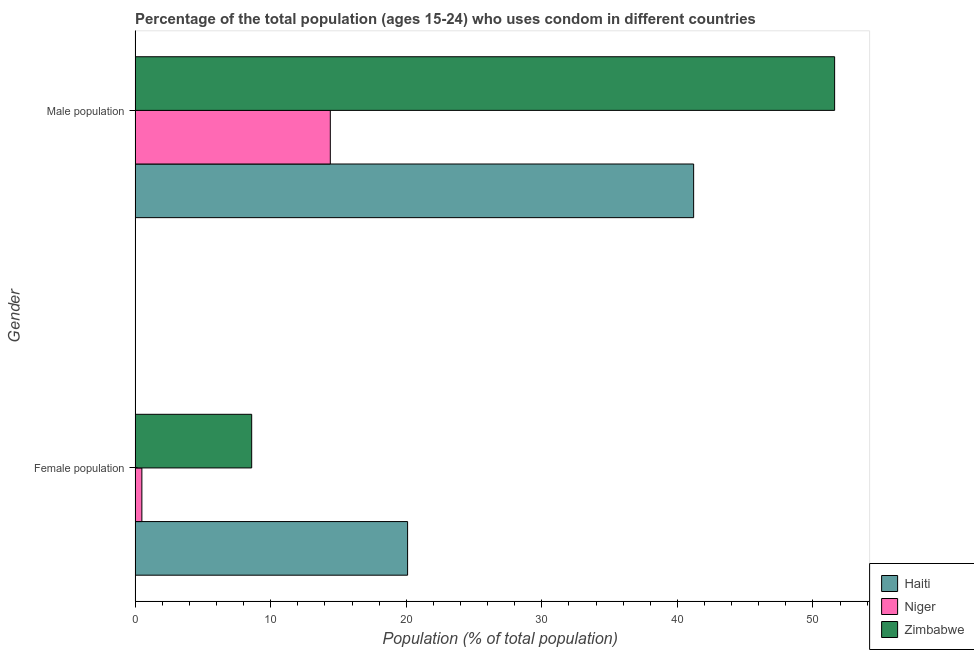How many different coloured bars are there?
Provide a short and direct response. 3. Are the number of bars per tick equal to the number of legend labels?
Your response must be concise. Yes. Are the number of bars on each tick of the Y-axis equal?
Offer a very short reply. Yes. What is the label of the 1st group of bars from the top?
Your answer should be very brief. Male population. What is the male population in Zimbabwe?
Offer a terse response. 51.6. Across all countries, what is the maximum female population?
Your answer should be very brief. 20.1. Across all countries, what is the minimum male population?
Offer a very short reply. 14.4. In which country was the female population maximum?
Offer a terse response. Haiti. In which country was the male population minimum?
Offer a terse response. Niger. What is the total male population in the graph?
Give a very brief answer. 107.2. What is the difference between the male population in Haiti and that in Niger?
Your answer should be compact. 26.8. What is the difference between the male population in Haiti and the female population in Zimbabwe?
Your answer should be compact. 32.6. What is the average male population per country?
Offer a very short reply. 35.73. What is the difference between the female population and male population in Zimbabwe?
Give a very brief answer. -43. What is the ratio of the female population in Haiti to that in Zimbabwe?
Offer a very short reply. 2.34. Is the female population in Zimbabwe less than that in Haiti?
Your response must be concise. Yes. What does the 1st bar from the top in Female population represents?
Ensure brevity in your answer.  Zimbabwe. What does the 2nd bar from the bottom in Female population represents?
Keep it short and to the point. Niger. Are all the bars in the graph horizontal?
Your answer should be very brief. Yes. How many countries are there in the graph?
Offer a very short reply. 3. What is the difference between two consecutive major ticks on the X-axis?
Provide a succinct answer. 10. What is the title of the graph?
Provide a short and direct response. Percentage of the total population (ages 15-24) who uses condom in different countries. What is the label or title of the X-axis?
Offer a very short reply. Population (% of total population) . What is the label or title of the Y-axis?
Make the answer very short. Gender. What is the Population (% of total population)  in Haiti in Female population?
Offer a very short reply. 20.1. What is the Population (% of total population)  in Zimbabwe in Female population?
Make the answer very short. 8.6. What is the Population (% of total population)  of Haiti in Male population?
Your answer should be very brief. 41.2. What is the Population (% of total population)  in Niger in Male population?
Make the answer very short. 14.4. What is the Population (% of total population)  of Zimbabwe in Male population?
Offer a terse response. 51.6. Across all Gender, what is the maximum Population (% of total population)  in Haiti?
Offer a terse response. 41.2. Across all Gender, what is the maximum Population (% of total population)  of Zimbabwe?
Give a very brief answer. 51.6. Across all Gender, what is the minimum Population (% of total population)  of Haiti?
Your answer should be very brief. 20.1. Across all Gender, what is the minimum Population (% of total population)  in Niger?
Offer a terse response. 0.5. What is the total Population (% of total population)  in Haiti in the graph?
Make the answer very short. 61.3. What is the total Population (% of total population)  in Niger in the graph?
Give a very brief answer. 14.9. What is the total Population (% of total population)  in Zimbabwe in the graph?
Ensure brevity in your answer.  60.2. What is the difference between the Population (% of total population)  of Haiti in Female population and that in Male population?
Make the answer very short. -21.1. What is the difference between the Population (% of total population)  in Niger in Female population and that in Male population?
Your response must be concise. -13.9. What is the difference between the Population (% of total population)  of Zimbabwe in Female population and that in Male population?
Provide a short and direct response. -43. What is the difference between the Population (% of total population)  of Haiti in Female population and the Population (% of total population)  of Niger in Male population?
Offer a very short reply. 5.7. What is the difference between the Population (% of total population)  of Haiti in Female population and the Population (% of total population)  of Zimbabwe in Male population?
Provide a short and direct response. -31.5. What is the difference between the Population (% of total population)  of Niger in Female population and the Population (% of total population)  of Zimbabwe in Male population?
Make the answer very short. -51.1. What is the average Population (% of total population)  in Haiti per Gender?
Your answer should be very brief. 30.65. What is the average Population (% of total population)  of Niger per Gender?
Provide a succinct answer. 7.45. What is the average Population (% of total population)  of Zimbabwe per Gender?
Your answer should be compact. 30.1. What is the difference between the Population (% of total population)  in Haiti and Population (% of total population)  in Niger in Female population?
Give a very brief answer. 19.6. What is the difference between the Population (% of total population)  of Haiti and Population (% of total population)  of Zimbabwe in Female population?
Give a very brief answer. 11.5. What is the difference between the Population (% of total population)  of Niger and Population (% of total population)  of Zimbabwe in Female population?
Your answer should be compact. -8.1. What is the difference between the Population (% of total population)  in Haiti and Population (% of total population)  in Niger in Male population?
Offer a very short reply. 26.8. What is the difference between the Population (% of total population)  in Niger and Population (% of total population)  in Zimbabwe in Male population?
Ensure brevity in your answer.  -37.2. What is the ratio of the Population (% of total population)  of Haiti in Female population to that in Male population?
Provide a succinct answer. 0.49. What is the ratio of the Population (% of total population)  in Niger in Female population to that in Male population?
Keep it short and to the point. 0.03. What is the difference between the highest and the second highest Population (% of total population)  of Haiti?
Offer a terse response. 21.1. What is the difference between the highest and the second highest Population (% of total population)  of Niger?
Offer a terse response. 13.9. What is the difference between the highest and the second highest Population (% of total population)  of Zimbabwe?
Your response must be concise. 43. What is the difference between the highest and the lowest Population (% of total population)  in Haiti?
Your response must be concise. 21.1. What is the difference between the highest and the lowest Population (% of total population)  in Niger?
Offer a very short reply. 13.9. What is the difference between the highest and the lowest Population (% of total population)  in Zimbabwe?
Make the answer very short. 43. 